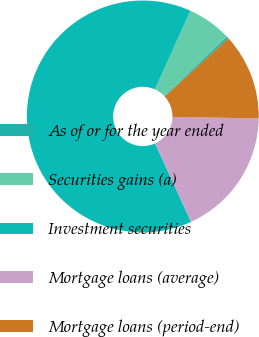Convert chart. <chart><loc_0><loc_0><loc_500><loc_500><pie_chart><fcel>As of or for the year ended<fcel>Securities gains (a)<fcel>Investment securities<fcel>Mortgage loans (average)<fcel>Mortgage loans (period-end)<nl><fcel>0.32%<fcel>6.18%<fcel>63.56%<fcel>17.9%<fcel>12.04%<nl></chart> 